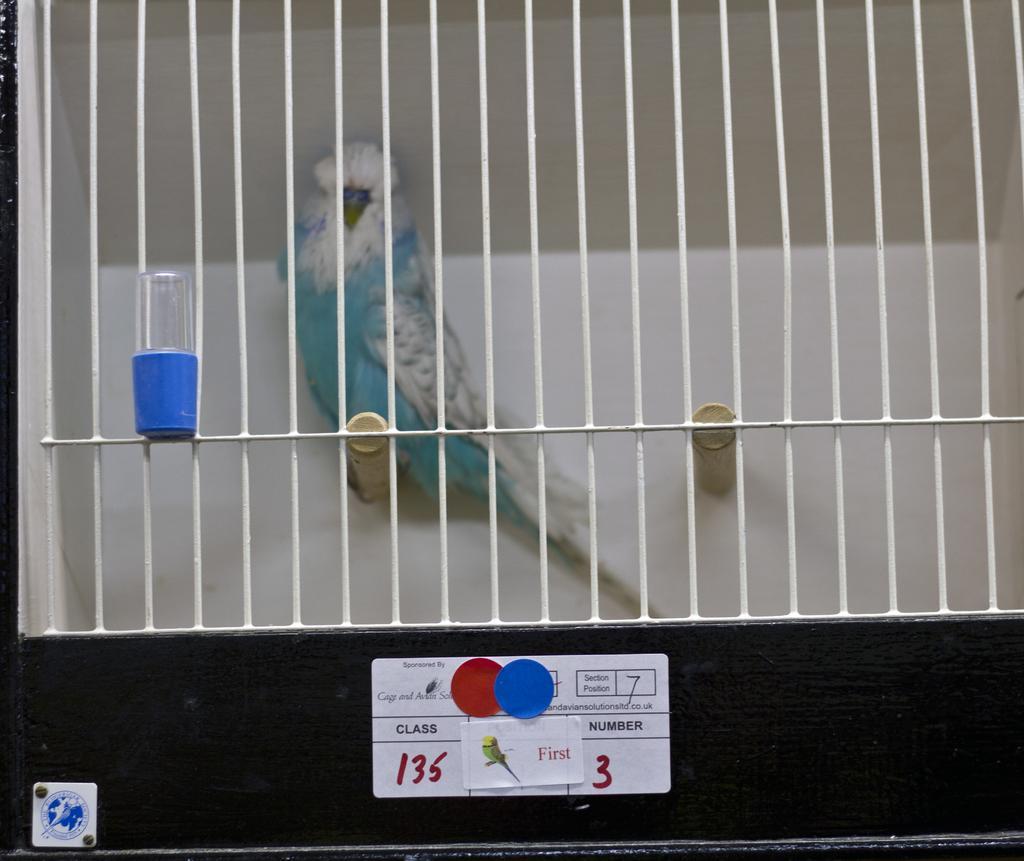Please provide a concise description of this image. In this image there is a cage, and in the case there is a bird and some object and also at the bottom there are some boards. On the boards there is text, and in the background there is wall. 